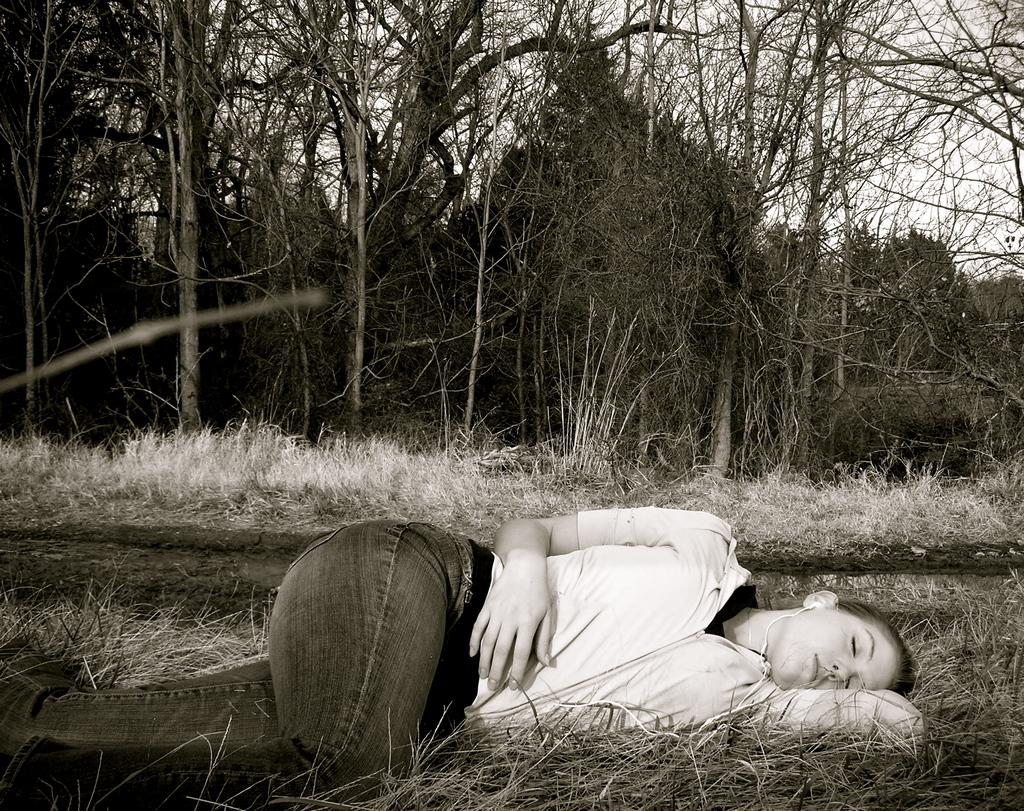Who is present in the image? There is a woman in the image. What is the woman doing in the image? The woman is sleeping on the ground. What type of natural environment is visible in the image? There is grass and trees visible in the image. What is the woman smashing in the image? There is no mention of the woman smashing anything in the image. 